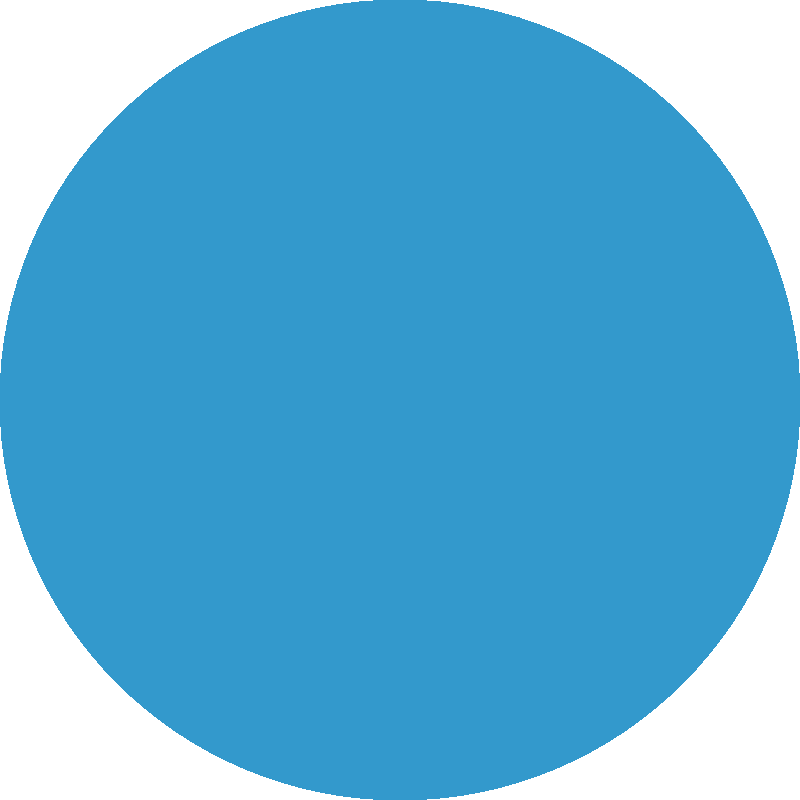As a corporate attorney specializing in intellectual property law, you are advising a client on the similarity of two logos in a potential trademark infringement case. Based on the visual comparison of Logo A and Logo B, what legal principle would you apply to assess their similarity, and how might this impact your client's position in a trademark dispute? To assess the similarity of Logo A and Logo B in a trademark infringement case, we would apply the following legal principles and considerations:

1. Overall impression: Both logos use a similar shade of blue and are simple geometric shapes, which could create a similar overall impression to consumers.

2. Likelihood of confusion test: We would apply the multi-factor test used in trademark law, which includes:
   a) Similarity of the marks
   b) Strength of the plaintiff's mark
   c) Proximity of the goods or services
   d) Evidence of actual confusion
   e) Marketing channels used
   f) Degree of consumer care
   g) Defendant's intent in selecting the mark

3. Visual similarity: While both logos are geometric shapes, Logo A is a circle, and Logo B is a hexagon. This difference might be significant enough to distinguish them visually.

4. Conceptual similarity: Both logos use simple geometric shapes, which could be seen as conceptually similar in their minimalist approach.

5. Commercial impression: The simplicity of both logos might create a similar commercial impression, particularly if used in similar markets or industries.

6. Trademark strength: The strength of each mark would need to be considered. Simple geometric shapes might be considered weak marks unless they have acquired secondary meaning through extensive use and recognition.

7. Context of use: The specific industry and how these logos are used in commerce would be crucial in determining the likelihood of confusion.

8. Distinctiveness: We would need to assess whether either logo has acquired distinctiveness through use in commerce, as simple geometric shapes are generally not inherently distinctive.

Given these considerations, we would likely advise the client that while there are some similarities between the logos, the distinct geometric shapes (circle vs. hexagon) provide a basis for arguing that they are sufficiently different to avoid likelihood of confusion. However, the final determination would depend on additional factors such as the strength of each mark, the specific industries involved, and any evidence of actual confusion in the marketplace.
Answer: Apply the likelihood of confusion test, focusing on visual and conceptual similarities while considering the distinct geometric shapes (circle vs. hexagon) as a potential differentiating factor. 